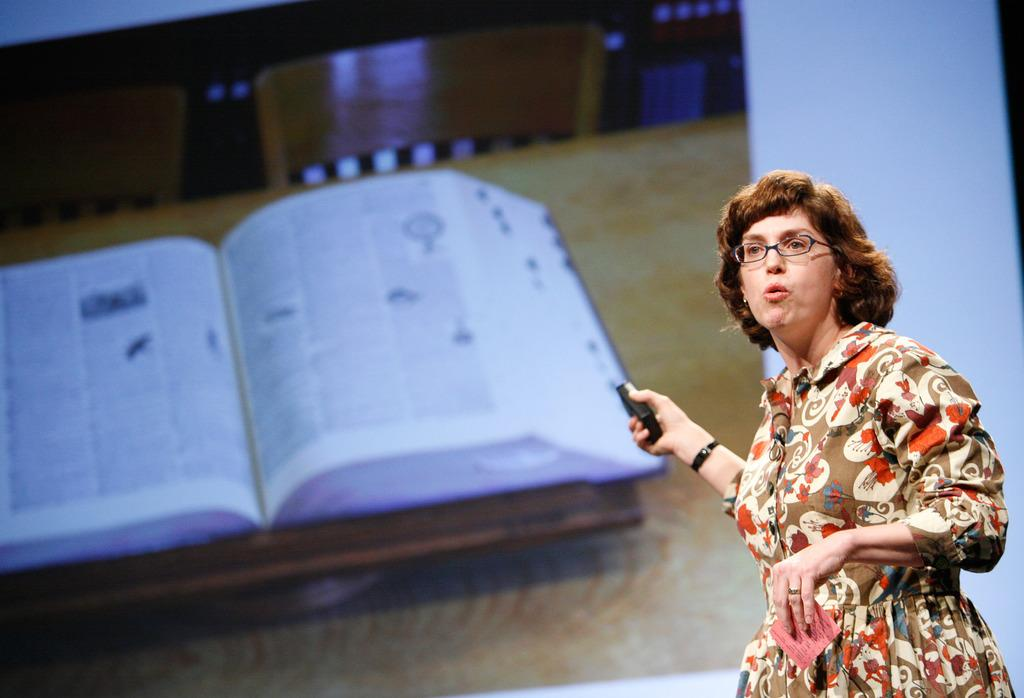What is the main subject of the image? There is a woman in the image. What is the woman holding in her hands? The woman is holding a device and a paper in her hands. What is the woman's posture in the image? The woman is standing in the image. What can be seen in the background of the image? There is a screen in the background of the image. What is on the screen? A book is visible on the surface of the screen. How many children are playing with the beast in the image? There are no children or beasts present in the image. What type of beetle can be seen crawling on the book in the image? There are no beetles visible in the image, and the book is on the screen, not on the ground. 